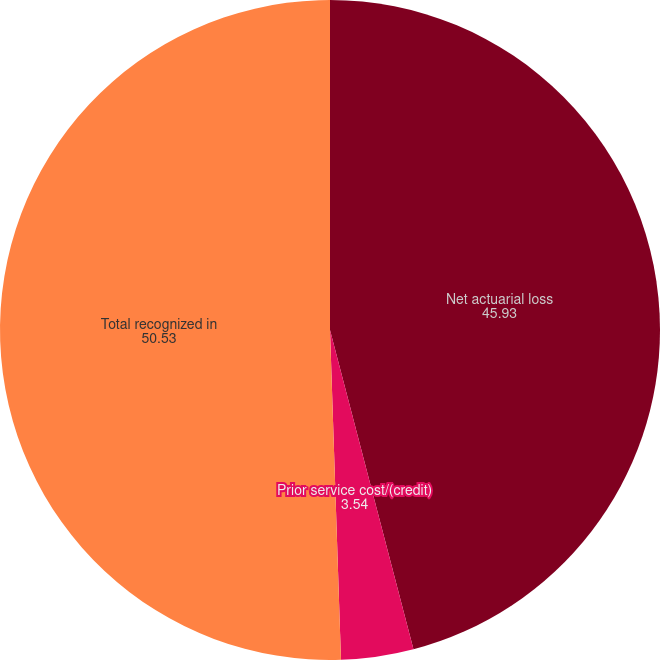Convert chart. <chart><loc_0><loc_0><loc_500><loc_500><pie_chart><fcel>Net actuarial loss<fcel>Prior service cost/(credit)<fcel>Total recognized in<nl><fcel>45.93%<fcel>3.54%<fcel>50.53%<nl></chart> 